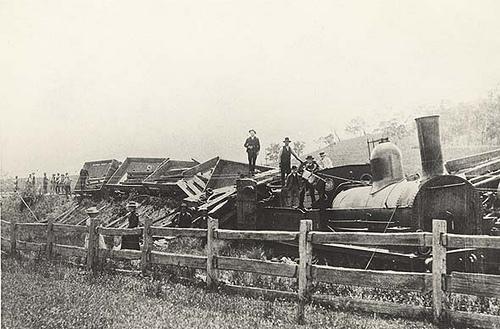Is this image in black and white?
Concise answer only. Yes. Is this train ready to transport people?
Keep it brief. No. Are the men wearing hats?
Write a very short answer. Yes. 